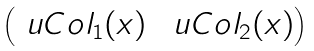<formula> <loc_0><loc_0><loc_500><loc_500>\begin{pmatrix} \ u C o l _ { 1 } ( x ) & \ u C o l _ { 2 } ( x ) \end{pmatrix}</formula> 